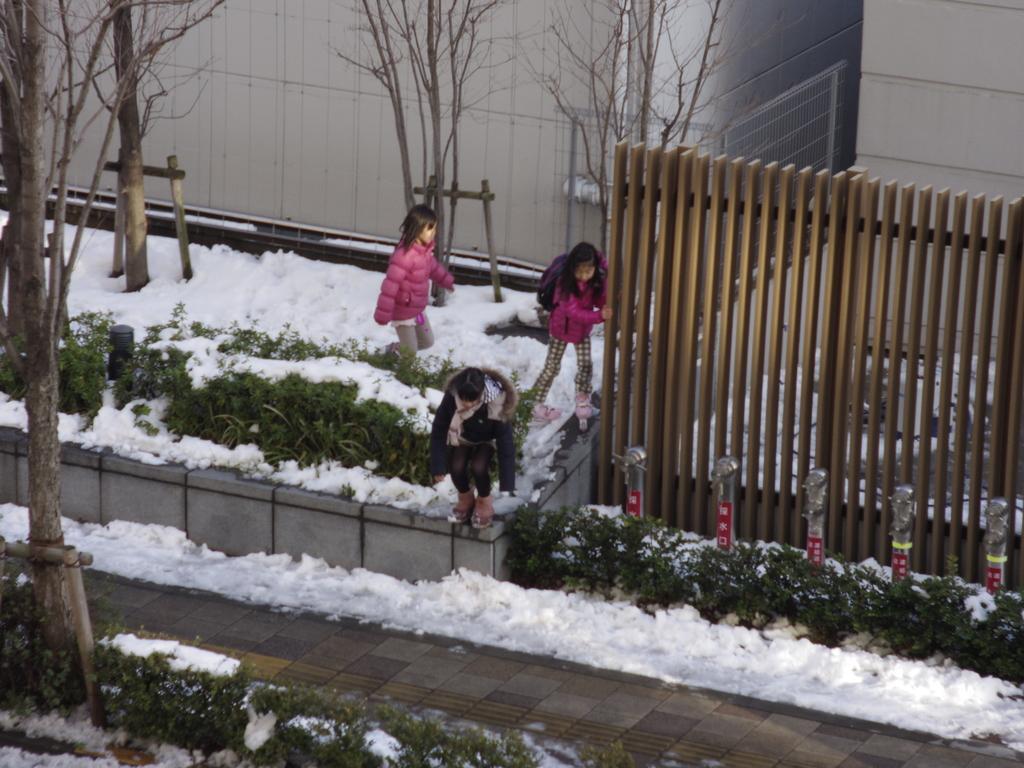Can you describe this image briefly? In the image there are three kids in pink jerking standing beside a fence on the snow land. 